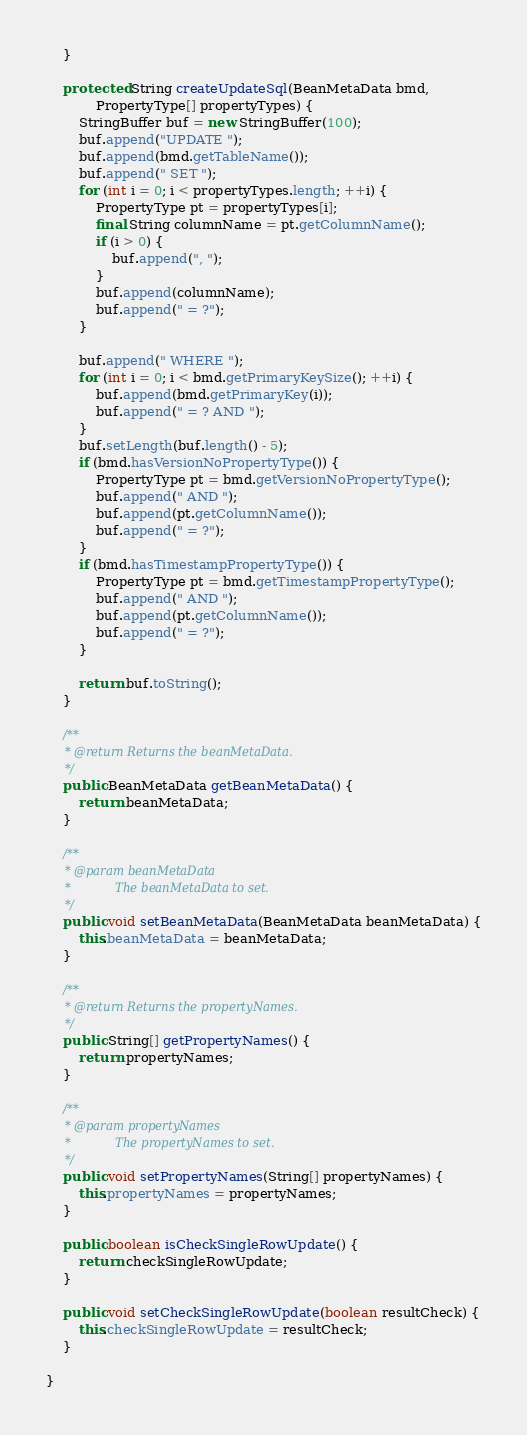<code> <loc_0><loc_0><loc_500><loc_500><_Java_>    }

    protected String createUpdateSql(BeanMetaData bmd,
            PropertyType[] propertyTypes) {
        StringBuffer buf = new StringBuffer(100);
        buf.append("UPDATE ");
        buf.append(bmd.getTableName());
        buf.append(" SET ");
        for (int i = 0; i < propertyTypes.length; ++i) {
            PropertyType pt = propertyTypes[i];
            final String columnName = pt.getColumnName();
            if (i > 0) {
                buf.append(", ");
            }
            buf.append(columnName);
            buf.append(" = ?");
        }

        buf.append(" WHERE ");
        for (int i = 0; i < bmd.getPrimaryKeySize(); ++i) {
            buf.append(bmd.getPrimaryKey(i));
            buf.append(" = ? AND ");
        }
        buf.setLength(buf.length() - 5);
        if (bmd.hasVersionNoPropertyType()) {
            PropertyType pt = bmd.getVersionNoPropertyType();
            buf.append(" AND ");
            buf.append(pt.getColumnName());
            buf.append(" = ?");
        }
        if (bmd.hasTimestampPropertyType()) {
            PropertyType pt = bmd.getTimestampPropertyType();
            buf.append(" AND ");
            buf.append(pt.getColumnName());
            buf.append(" = ?");
        }

        return buf.toString();
    }

    /**
     * @return Returns the beanMetaData.
     */
    public BeanMetaData getBeanMetaData() {
        return beanMetaData;
    }

    /**
     * @param beanMetaData
     *            The beanMetaData to set.
     */
    public void setBeanMetaData(BeanMetaData beanMetaData) {
        this.beanMetaData = beanMetaData;
    }

    /**
     * @return Returns the propertyNames.
     */
    public String[] getPropertyNames() {
        return propertyNames;
    }

    /**
     * @param propertyNames
     *            The propertyNames to set.
     */
    public void setPropertyNames(String[] propertyNames) {
        this.propertyNames = propertyNames;
    }

    public boolean isCheckSingleRowUpdate() {
        return checkSingleRowUpdate;
    }

    public void setCheckSingleRowUpdate(boolean resultCheck) {
        this.checkSingleRowUpdate = resultCheck;
    }

}
</code> 